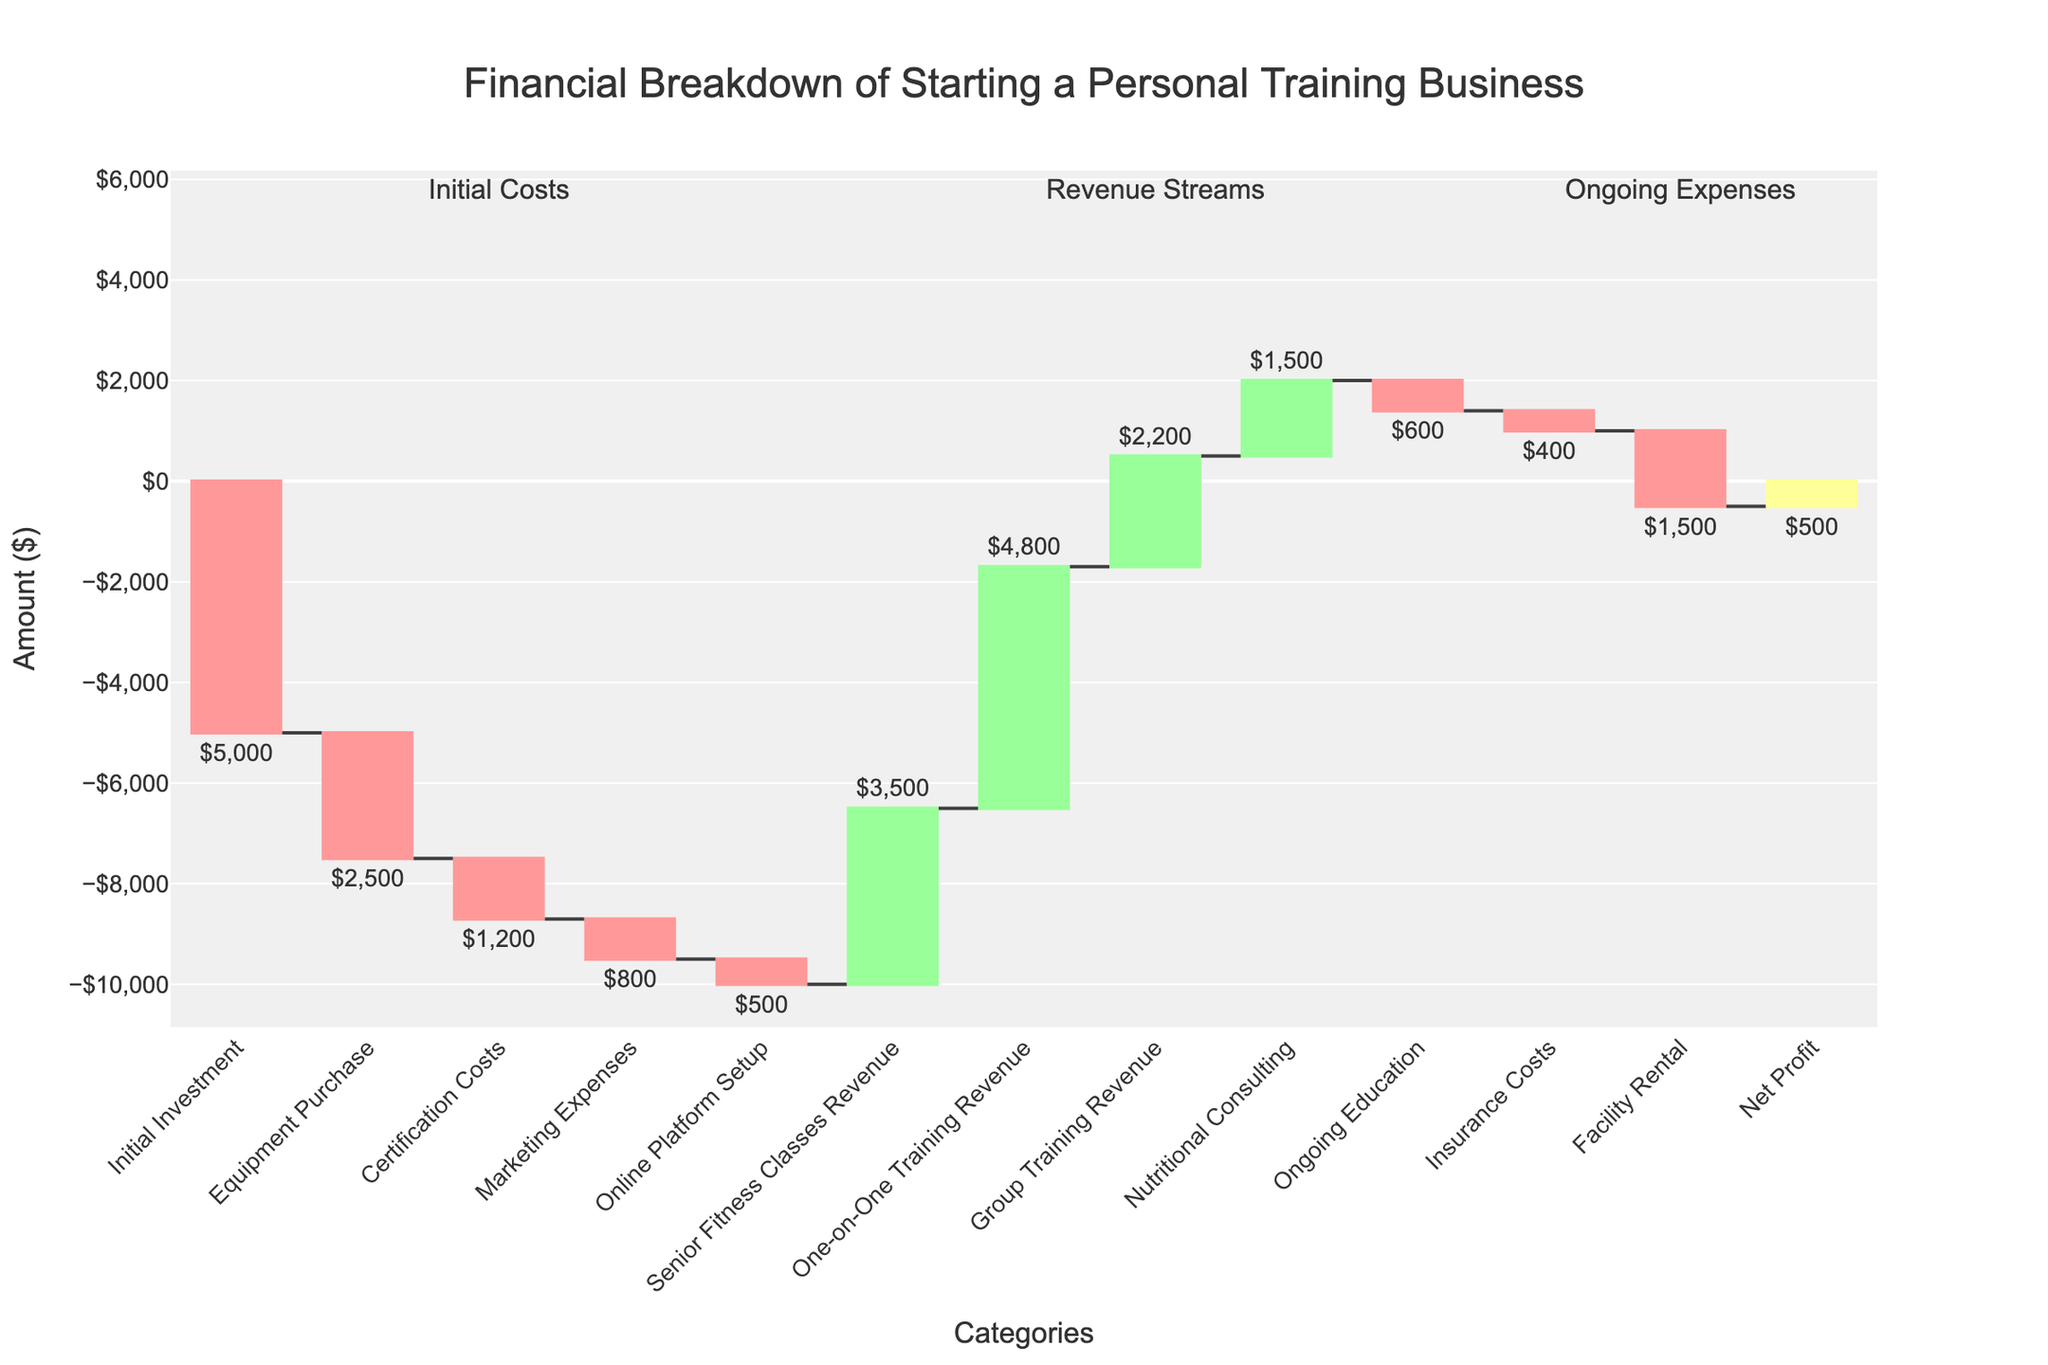What is the total initial investment cost? To find the total initial investment cost, add the initial investments related to 'Initial Investment', 'Equipment Purchase', 'Certification Costs', 'Marketing Expenses', and 'Online Platform Setup': $5000 + $2500 + $1200 + $800 + $500.
Answer: $10,000 How much net profit does the business make based on the chart? The net profit is directly given in the chart as a final value. This value is $500.
Answer: $500 What is the highest revenue stream and its amount? Compare the amounts of all revenue streams: 'Senior Fitness Classes Revenue' ($3500), 'One-on-One Training Revenue' ($4800), 'Group Training Revenue' ($2200), and 'Nutritional Consulting' ($1500). The highest is 'One-on-One Training Revenue' at $4800.
Answer: One-on-One Training Revenue, $4800 How do overall revenues compare to overall ongoing expenses? Compare the sum of the revenue streams to the sum of ongoing expenses. Revenue Streams = $3500 + $4800 + $2200 + $1500 = $12000; Ongoing Expenses = $600 (Ongoing Education) + $400 (Insurance Costs) + $1500 (Facility Rental) = $2500.
Answer: Revenues are higher by $9500 Which is costlier: Equipment Purchase or Facility Rental? Compare the amounts for 'Equipment Purchase' ($2500) and 'Facility Rental' ($1500). Equipment Purchase costs more.
Answer: Equipment Purchase Which section has the most impact on the business finances in terms of expenditure? Sum up the expenditures: 'Initial Investment', 'Equipment Purchase', 'Certification Costs', 'Marketing Expenses', 'Online Platform Setup', 'Ongoing Education', 'Insurance Costs', 'Facility Rental'. The initial investments cost a total of $10,000 which is the largest section.
Answer: Initial investments, $10,000 How do the overall expenditures compare to the overall revenues? Calculate the sum of all expenditures and sum of all revenues, then compare: Total Expenditures = $10,000 (Initial Investments) + $2500 (Ongoing Expenses) = $12500; Total Revenues = $12000. Expenditures exceed revenues by $500. This makes sense as the net profit is $500.
Answer: Expenditures exceed by $500 If the revenue from Senior Fitness Classes doubles, what will be the new net profit? The initial net profit is $500. Doubling the Senior Fitness Classes Revenue adds another $3500, leading to a new net profit of $4000 ($500 existing net profit + $3500 additional revenue).
Answer: $4000 Which costs more: Certification Costs or Insurance Costs? Certification Costs are $1200, while Insurance Costs are $400. Certification Costs are higher.
Answer: Certification Costs What is the difference between the costs of Marketing Expenses and Online Platform Setup? The costs of Marketing Expenses and Online Platform Setup are $800 and $500 respectively. The difference is $800 - $500 = $300.
Answer: $300 